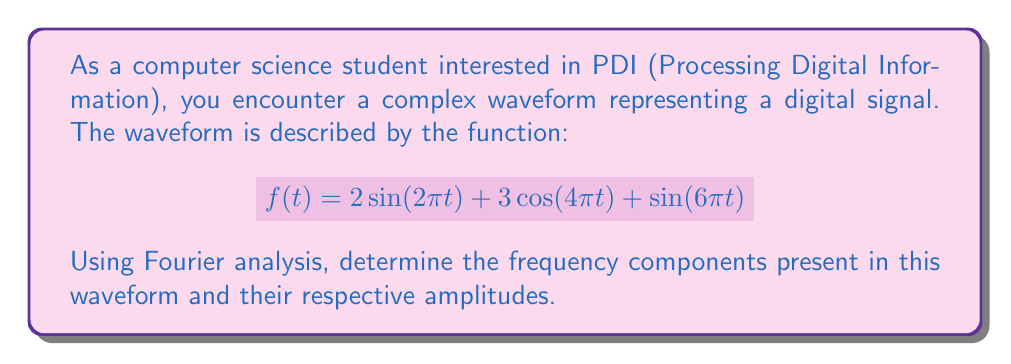Can you solve this math problem? To determine the frequency components and their amplitudes using Fourier analysis, we need to identify the individual sinusoidal components in the given function. Let's break this down step-by-step:

1. The given function is:
   $$f(t) = 2\sin(2\pi t) + 3\cos(4\pi t) + \sin(6\pi t)$$

2. In general, a sinusoidal function can be written as $A\sin(2\pi ft)$ or $A\cos(2\pi ft)$, where $A$ is the amplitude and $f$ is the frequency.

3. Let's analyze each term:

   a. $2\sin(2\pi t)$:
      - Amplitude: $A_1 = 2$
      - Frequency: $f_1 = 1$ Hz (because $2\pi t = 2\pi f_1 t$)

   b. $3\cos(4\pi t)$:
      - Amplitude: $A_2 = 3$
      - Frequency: $f_2 = 2$ Hz (because $4\pi t = 2\pi f_2 t$)

   c. $\sin(6\pi t)$:
      - Amplitude: $A_3 = 1$
      - Frequency: $f_3 = 3$ Hz (because $6\pi t = 2\pi f_3 t$)

4. The frequency components are the frequencies we identified: 1 Hz, 2 Hz, and 3 Hz.

5. The amplitudes correspond to these frequencies:
   - 1 Hz component has an amplitude of 2
   - 2 Hz component has an amplitude of 3
   - 3 Hz component has an amplitude of 1

Therefore, the waveform consists of three frequency components: 1 Hz, 2 Hz, and 3 Hz, with amplitudes 2, 3, and 1 respectively.
Answer: The frequency components and their amplitudes are:
1 Hz with amplitude 2
2 Hz with amplitude 3
3 Hz with amplitude 1 